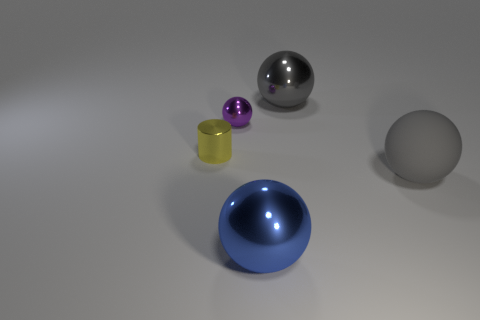What is the material of the gray ball that is behind the tiny yellow object?
Give a very brief answer. Metal. Is the number of large blue shiny balls to the right of the big gray metallic sphere the same as the number of big gray shiny spheres?
Offer a very short reply. No. Are there any other things that are the same size as the blue metallic object?
Provide a short and direct response. Yes. There is a large ball that is to the left of the gray object that is behind the small purple shiny ball; what is it made of?
Your answer should be compact. Metal. The metallic object that is on the right side of the small yellow shiny cylinder and to the left of the blue object has what shape?
Give a very brief answer. Sphere. What is the size of the gray metallic thing that is the same shape as the large blue metallic thing?
Give a very brief answer. Large. Are there fewer big things in front of the small yellow cylinder than cylinders?
Your answer should be compact. No. How big is the ball that is left of the big blue shiny object?
Provide a short and direct response. Small. There is a big rubber object that is the same shape as the tiny purple object; what color is it?
Offer a very short reply. Gray. What number of balls have the same color as the tiny cylinder?
Offer a terse response. 0. 